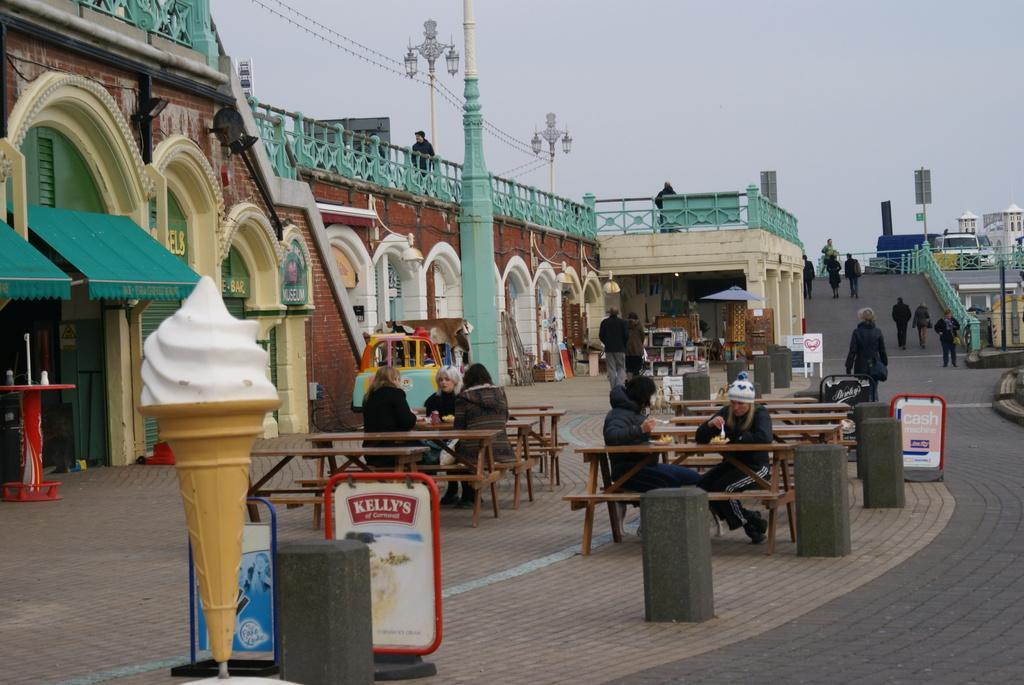Please provide a concise description of this image. At the top we can see sky and it seems like a cloudy day. here we can stores. we can see few persons sitting on the benches and eating some food. This is a hoarding. Itś an artificial ice cream. Here we can see table near to the store. Here we can see few persons walking on the road. This is a building. Here we can see vehicle on the road. We can see few persons here. These are lights. 